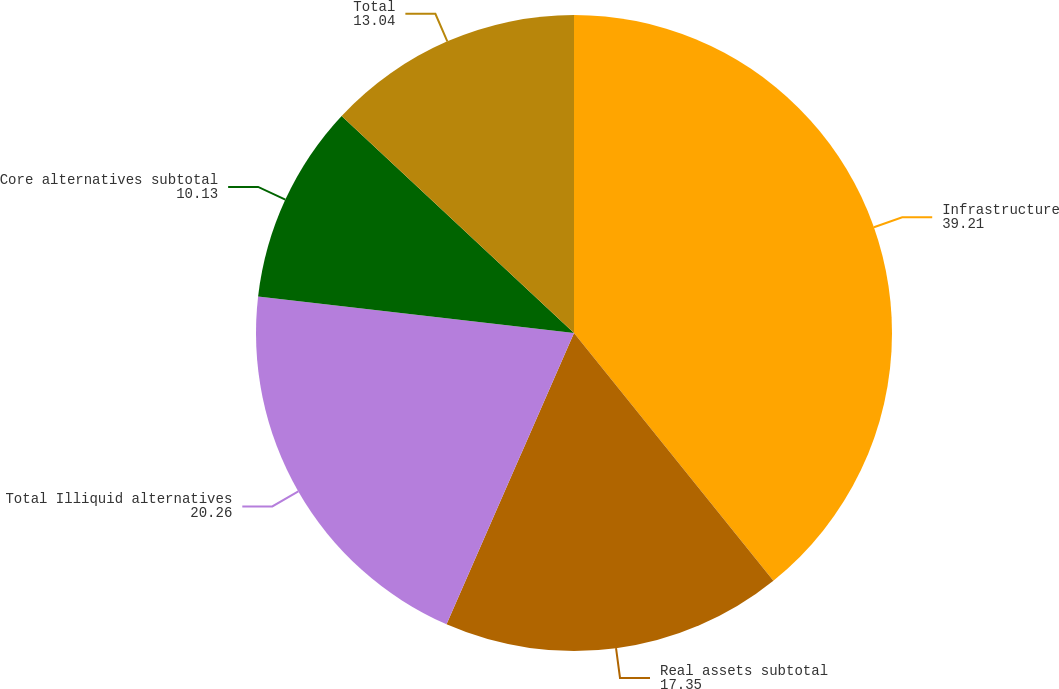Convert chart. <chart><loc_0><loc_0><loc_500><loc_500><pie_chart><fcel>Infrastructure<fcel>Real assets subtotal<fcel>Total Illiquid alternatives<fcel>Core alternatives subtotal<fcel>Total<nl><fcel>39.21%<fcel>17.35%<fcel>20.26%<fcel>10.13%<fcel>13.04%<nl></chart> 